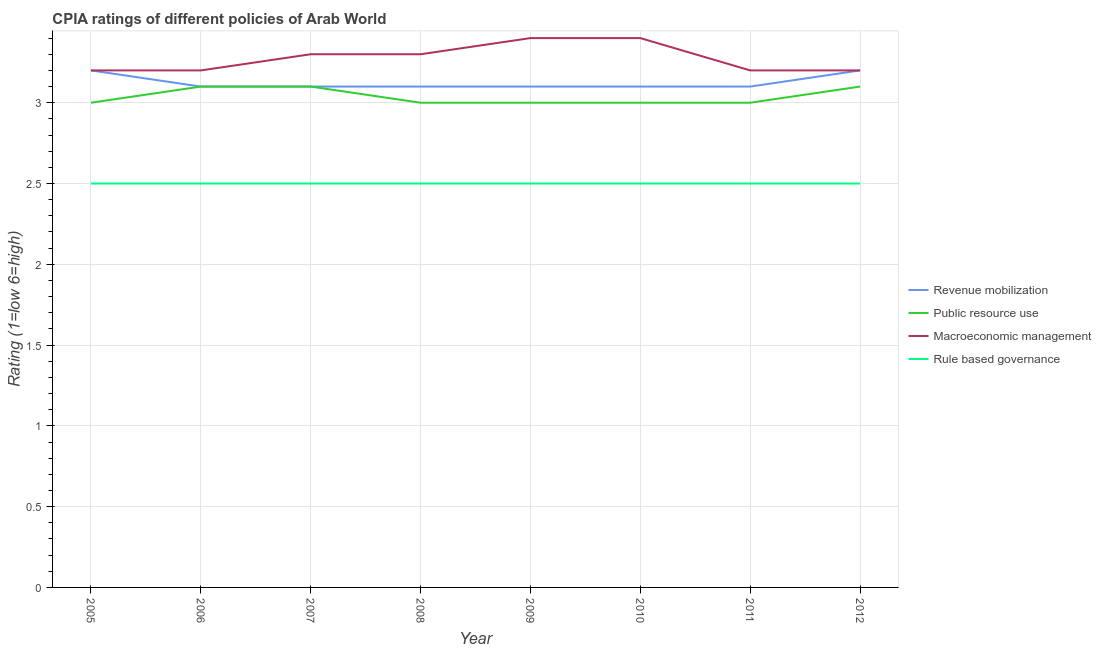How many different coloured lines are there?
Offer a very short reply. 4. Across all years, what is the maximum cpia rating of macroeconomic management?
Ensure brevity in your answer.  3.4. In which year was the cpia rating of rule based governance maximum?
Make the answer very short. 2005. What is the total cpia rating of macroeconomic management in the graph?
Keep it short and to the point. 26.2. What is the difference between the cpia rating of revenue mobilization in 2012 and the cpia rating of macroeconomic management in 2010?
Provide a short and direct response. -0.2. What is the average cpia rating of revenue mobilization per year?
Ensure brevity in your answer.  3.12. In the year 2006, what is the difference between the cpia rating of macroeconomic management and cpia rating of revenue mobilization?
Provide a succinct answer. 0.1. In how many years, is the cpia rating of public resource use greater than 2.6?
Offer a terse response. 8. What is the ratio of the cpia rating of rule based governance in 2005 to that in 2010?
Your response must be concise. 1. Is the cpia rating of macroeconomic management in 2009 less than that in 2012?
Give a very brief answer. No. What is the difference between the highest and the lowest cpia rating of revenue mobilization?
Provide a succinct answer. 0.1. Is the sum of the cpia rating of public resource use in 2005 and 2012 greater than the maximum cpia rating of rule based governance across all years?
Give a very brief answer. Yes. Is the cpia rating of macroeconomic management strictly less than the cpia rating of public resource use over the years?
Your answer should be compact. No. How many years are there in the graph?
Provide a succinct answer. 8. What is the difference between two consecutive major ticks on the Y-axis?
Ensure brevity in your answer.  0.5. Are the values on the major ticks of Y-axis written in scientific E-notation?
Offer a very short reply. No. Does the graph contain any zero values?
Offer a terse response. No. Where does the legend appear in the graph?
Provide a short and direct response. Center right. How are the legend labels stacked?
Keep it short and to the point. Vertical. What is the title of the graph?
Provide a short and direct response. CPIA ratings of different policies of Arab World. What is the label or title of the X-axis?
Ensure brevity in your answer.  Year. What is the Rating (1=low 6=high) in Macroeconomic management in 2005?
Your answer should be very brief. 3.2. What is the Rating (1=low 6=high) of Rule based governance in 2005?
Keep it short and to the point. 2.5. What is the Rating (1=low 6=high) in Macroeconomic management in 2006?
Your answer should be very brief. 3.2. What is the Rating (1=low 6=high) in Rule based governance in 2006?
Ensure brevity in your answer.  2.5. What is the Rating (1=low 6=high) in Rule based governance in 2007?
Provide a short and direct response. 2.5. What is the Rating (1=low 6=high) of Revenue mobilization in 2008?
Your answer should be very brief. 3.1. What is the Rating (1=low 6=high) in Macroeconomic management in 2008?
Make the answer very short. 3.3. What is the Rating (1=low 6=high) in Macroeconomic management in 2009?
Provide a short and direct response. 3.4. What is the Rating (1=low 6=high) of Revenue mobilization in 2010?
Make the answer very short. 3.1. What is the Rating (1=low 6=high) in Public resource use in 2010?
Give a very brief answer. 3. What is the Rating (1=low 6=high) in Macroeconomic management in 2010?
Provide a short and direct response. 3.4. What is the Rating (1=low 6=high) of Rule based governance in 2011?
Give a very brief answer. 2.5. What is the Rating (1=low 6=high) of Revenue mobilization in 2012?
Your answer should be very brief. 3.2. Across all years, what is the maximum Rating (1=low 6=high) of Revenue mobilization?
Offer a terse response. 3.2. Across all years, what is the maximum Rating (1=low 6=high) in Macroeconomic management?
Offer a very short reply. 3.4. Across all years, what is the maximum Rating (1=low 6=high) in Rule based governance?
Offer a terse response. 2.5. What is the total Rating (1=low 6=high) of Revenue mobilization in the graph?
Your answer should be very brief. 25. What is the total Rating (1=low 6=high) in Public resource use in the graph?
Your answer should be compact. 24.3. What is the total Rating (1=low 6=high) of Macroeconomic management in the graph?
Your answer should be compact. 26.2. What is the difference between the Rating (1=low 6=high) in Rule based governance in 2005 and that in 2006?
Offer a terse response. 0. What is the difference between the Rating (1=low 6=high) in Revenue mobilization in 2005 and that in 2007?
Your response must be concise. 0.1. What is the difference between the Rating (1=low 6=high) in Macroeconomic management in 2005 and that in 2007?
Offer a very short reply. -0.1. What is the difference between the Rating (1=low 6=high) of Revenue mobilization in 2005 and that in 2008?
Ensure brevity in your answer.  0.1. What is the difference between the Rating (1=low 6=high) in Macroeconomic management in 2005 and that in 2008?
Give a very brief answer. -0.1. What is the difference between the Rating (1=low 6=high) in Rule based governance in 2005 and that in 2008?
Your response must be concise. 0. What is the difference between the Rating (1=low 6=high) of Revenue mobilization in 2005 and that in 2009?
Keep it short and to the point. 0.1. What is the difference between the Rating (1=low 6=high) of Public resource use in 2005 and that in 2010?
Your answer should be compact. 0. What is the difference between the Rating (1=low 6=high) in Rule based governance in 2005 and that in 2010?
Ensure brevity in your answer.  0. What is the difference between the Rating (1=low 6=high) in Public resource use in 2005 and that in 2011?
Keep it short and to the point. 0. What is the difference between the Rating (1=low 6=high) of Macroeconomic management in 2005 and that in 2011?
Ensure brevity in your answer.  0. What is the difference between the Rating (1=low 6=high) in Rule based governance in 2005 and that in 2011?
Provide a succinct answer. 0. What is the difference between the Rating (1=low 6=high) in Public resource use in 2005 and that in 2012?
Keep it short and to the point. -0.1. What is the difference between the Rating (1=low 6=high) in Rule based governance in 2005 and that in 2012?
Provide a short and direct response. 0. What is the difference between the Rating (1=low 6=high) in Revenue mobilization in 2006 and that in 2007?
Your response must be concise. 0. What is the difference between the Rating (1=low 6=high) in Revenue mobilization in 2006 and that in 2008?
Your answer should be very brief. 0. What is the difference between the Rating (1=low 6=high) in Macroeconomic management in 2006 and that in 2008?
Offer a terse response. -0.1. What is the difference between the Rating (1=low 6=high) in Revenue mobilization in 2006 and that in 2011?
Make the answer very short. 0. What is the difference between the Rating (1=low 6=high) of Public resource use in 2006 and that in 2011?
Offer a terse response. 0.1. What is the difference between the Rating (1=low 6=high) of Rule based governance in 2006 and that in 2011?
Offer a terse response. 0. What is the difference between the Rating (1=low 6=high) in Revenue mobilization in 2006 and that in 2012?
Ensure brevity in your answer.  -0.1. What is the difference between the Rating (1=low 6=high) in Rule based governance in 2006 and that in 2012?
Provide a succinct answer. 0. What is the difference between the Rating (1=low 6=high) in Revenue mobilization in 2007 and that in 2008?
Make the answer very short. 0. What is the difference between the Rating (1=low 6=high) in Public resource use in 2007 and that in 2008?
Provide a short and direct response. 0.1. What is the difference between the Rating (1=low 6=high) in Public resource use in 2007 and that in 2009?
Give a very brief answer. 0.1. What is the difference between the Rating (1=low 6=high) in Macroeconomic management in 2007 and that in 2009?
Your response must be concise. -0.1. What is the difference between the Rating (1=low 6=high) in Revenue mobilization in 2007 and that in 2010?
Your response must be concise. 0. What is the difference between the Rating (1=low 6=high) of Revenue mobilization in 2007 and that in 2011?
Your response must be concise. 0. What is the difference between the Rating (1=low 6=high) in Public resource use in 2007 and that in 2011?
Your response must be concise. 0.1. What is the difference between the Rating (1=low 6=high) in Macroeconomic management in 2007 and that in 2011?
Your answer should be very brief. 0.1. What is the difference between the Rating (1=low 6=high) of Rule based governance in 2007 and that in 2011?
Offer a very short reply. 0. What is the difference between the Rating (1=low 6=high) in Revenue mobilization in 2007 and that in 2012?
Keep it short and to the point. -0.1. What is the difference between the Rating (1=low 6=high) of Public resource use in 2007 and that in 2012?
Give a very brief answer. 0. What is the difference between the Rating (1=low 6=high) of Rule based governance in 2007 and that in 2012?
Offer a terse response. 0. What is the difference between the Rating (1=low 6=high) of Macroeconomic management in 2008 and that in 2009?
Ensure brevity in your answer.  -0.1. What is the difference between the Rating (1=low 6=high) in Public resource use in 2008 and that in 2010?
Provide a short and direct response. 0. What is the difference between the Rating (1=low 6=high) in Public resource use in 2008 and that in 2011?
Give a very brief answer. 0. What is the difference between the Rating (1=low 6=high) of Macroeconomic management in 2008 and that in 2011?
Your answer should be compact. 0.1. What is the difference between the Rating (1=low 6=high) in Public resource use in 2008 and that in 2012?
Provide a short and direct response. -0.1. What is the difference between the Rating (1=low 6=high) in Revenue mobilization in 2009 and that in 2010?
Give a very brief answer. 0. What is the difference between the Rating (1=low 6=high) of Public resource use in 2009 and that in 2010?
Your response must be concise. 0. What is the difference between the Rating (1=low 6=high) of Macroeconomic management in 2009 and that in 2010?
Offer a terse response. 0. What is the difference between the Rating (1=low 6=high) in Revenue mobilization in 2009 and that in 2011?
Provide a short and direct response. 0. What is the difference between the Rating (1=low 6=high) in Public resource use in 2009 and that in 2011?
Your answer should be very brief. 0. What is the difference between the Rating (1=low 6=high) in Macroeconomic management in 2009 and that in 2012?
Your answer should be compact. 0.2. What is the difference between the Rating (1=low 6=high) of Revenue mobilization in 2010 and that in 2011?
Give a very brief answer. 0. What is the difference between the Rating (1=low 6=high) in Revenue mobilization in 2010 and that in 2012?
Your answer should be very brief. -0.1. What is the difference between the Rating (1=low 6=high) of Rule based governance in 2010 and that in 2012?
Offer a very short reply. 0. What is the difference between the Rating (1=low 6=high) in Public resource use in 2011 and that in 2012?
Give a very brief answer. -0.1. What is the difference between the Rating (1=low 6=high) in Rule based governance in 2011 and that in 2012?
Your answer should be compact. 0. What is the difference between the Rating (1=low 6=high) in Revenue mobilization in 2005 and the Rating (1=low 6=high) in Public resource use in 2006?
Offer a terse response. 0.1. What is the difference between the Rating (1=low 6=high) in Revenue mobilization in 2005 and the Rating (1=low 6=high) in Rule based governance in 2006?
Keep it short and to the point. 0.7. What is the difference between the Rating (1=low 6=high) of Public resource use in 2005 and the Rating (1=low 6=high) of Macroeconomic management in 2006?
Provide a succinct answer. -0.2. What is the difference between the Rating (1=low 6=high) of Macroeconomic management in 2005 and the Rating (1=low 6=high) of Rule based governance in 2006?
Give a very brief answer. 0.7. What is the difference between the Rating (1=low 6=high) of Revenue mobilization in 2005 and the Rating (1=low 6=high) of Public resource use in 2007?
Offer a very short reply. 0.1. What is the difference between the Rating (1=low 6=high) in Revenue mobilization in 2005 and the Rating (1=low 6=high) in Rule based governance in 2007?
Your response must be concise. 0.7. What is the difference between the Rating (1=low 6=high) of Public resource use in 2005 and the Rating (1=low 6=high) of Macroeconomic management in 2007?
Your response must be concise. -0.3. What is the difference between the Rating (1=low 6=high) of Public resource use in 2005 and the Rating (1=low 6=high) of Rule based governance in 2007?
Your response must be concise. 0.5. What is the difference between the Rating (1=low 6=high) in Revenue mobilization in 2005 and the Rating (1=low 6=high) in Public resource use in 2008?
Provide a succinct answer. 0.2. What is the difference between the Rating (1=low 6=high) of Revenue mobilization in 2005 and the Rating (1=low 6=high) of Rule based governance in 2008?
Offer a very short reply. 0.7. What is the difference between the Rating (1=low 6=high) in Public resource use in 2005 and the Rating (1=low 6=high) in Rule based governance in 2008?
Give a very brief answer. 0.5. What is the difference between the Rating (1=low 6=high) of Revenue mobilization in 2005 and the Rating (1=low 6=high) of Public resource use in 2009?
Make the answer very short. 0.2. What is the difference between the Rating (1=low 6=high) in Public resource use in 2005 and the Rating (1=low 6=high) in Macroeconomic management in 2009?
Your answer should be very brief. -0.4. What is the difference between the Rating (1=low 6=high) in Public resource use in 2005 and the Rating (1=low 6=high) in Rule based governance in 2009?
Offer a terse response. 0.5. What is the difference between the Rating (1=low 6=high) of Macroeconomic management in 2005 and the Rating (1=low 6=high) of Rule based governance in 2009?
Your response must be concise. 0.7. What is the difference between the Rating (1=low 6=high) in Revenue mobilization in 2005 and the Rating (1=low 6=high) in Rule based governance in 2010?
Provide a succinct answer. 0.7. What is the difference between the Rating (1=low 6=high) in Public resource use in 2005 and the Rating (1=low 6=high) in Rule based governance in 2010?
Give a very brief answer. 0.5. What is the difference between the Rating (1=low 6=high) of Macroeconomic management in 2005 and the Rating (1=low 6=high) of Rule based governance in 2010?
Your response must be concise. 0.7. What is the difference between the Rating (1=low 6=high) of Revenue mobilization in 2005 and the Rating (1=low 6=high) of Public resource use in 2011?
Give a very brief answer. 0.2. What is the difference between the Rating (1=low 6=high) in Revenue mobilization in 2005 and the Rating (1=low 6=high) in Macroeconomic management in 2011?
Provide a succinct answer. 0. What is the difference between the Rating (1=low 6=high) in Revenue mobilization in 2005 and the Rating (1=low 6=high) in Rule based governance in 2011?
Ensure brevity in your answer.  0.7. What is the difference between the Rating (1=low 6=high) of Public resource use in 2005 and the Rating (1=low 6=high) of Rule based governance in 2012?
Your answer should be very brief. 0.5. What is the difference between the Rating (1=low 6=high) in Public resource use in 2006 and the Rating (1=low 6=high) in Rule based governance in 2007?
Keep it short and to the point. 0.6. What is the difference between the Rating (1=low 6=high) in Macroeconomic management in 2006 and the Rating (1=low 6=high) in Rule based governance in 2007?
Your response must be concise. 0.7. What is the difference between the Rating (1=low 6=high) in Revenue mobilization in 2006 and the Rating (1=low 6=high) in Macroeconomic management in 2008?
Give a very brief answer. -0.2. What is the difference between the Rating (1=low 6=high) in Public resource use in 2006 and the Rating (1=low 6=high) in Macroeconomic management in 2008?
Make the answer very short. -0.2. What is the difference between the Rating (1=low 6=high) in Public resource use in 2006 and the Rating (1=low 6=high) in Rule based governance in 2008?
Your answer should be very brief. 0.6. What is the difference between the Rating (1=low 6=high) of Macroeconomic management in 2006 and the Rating (1=low 6=high) of Rule based governance in 2008?
Provide a succinct answer. 0.7. What is the difference between the Rating (1=low 6=high) of Revenue mobilization in 2006 and the Rating (1=low 6=high) of Public resource use in 2009?
Offer a terse response. 0.1. What is the difference between the Rating (1=low 6=high) in Revenue mobilization in 2006 and the Rating (1=low 6=high) in Macroeconomic management in 2009?
Offer a terse response. -0.3. What is the difference between the Rating (1=low 6=high) in Revenue mobilization in 2006 and the Rating (1=low 6=high) in Rule based governance in 2009?
Ensure brevity in your answer.  0.6. What is the difference between the Rating (1=low 6=high) in Public resource use in 2006 and the Rating (1=low 6=high) in Macroeconomic management in 2009?
Offer a terse response. -0.3. What is the difference between the Rating (1=low 6=high) in Public resource use in 2006 and the Rating (1=low 6=high) in Rule based governance in 2009?
Your answer should be very brief. 0.6. What is the difference between the Rating (1=low 6=high) of Macroeconomic management in 2006 and the Rating (1=low 6=high) of Rule based governance in 2009?
Keep it short and to the point. 0.7. What is the difference between the Rating (1=low 6=high) of Revenue mobilization in 2006 and the Rating (1=low 6=high) of Public resource use in 2010?
Provide a short and direct response. 0.1. What is the difference between the Rating (1=low 6=high) of Revenue mobilization in 2006 and the Rating (1=low 6=high) of Rule based governance in 2010?
Your response must be concise. 0.6. What is the difference between the Rating (1=low 6=high) of Public resource use in 2006 and the Rating (1=low 6=high) of Macroeconomic management in 2010?
Make the answer very short. -0.3. What is the difference between the Rating (1=low 6=high) in Public resource use in 2006 and the Rating (1=low 6=high) in Macroeconomic management in 2011?
Your answer should be very brief. -0.1. What is the difference between the Rating (1=low 6=high) of Revenue mobilization in 2006 and the Rating (1=low 6=high) of Public resource use in 2012?
Your response must be concise. 0. What is the difference between the Rating (1=low 6=high) of Revenue mobilization in 2006 and the Rating (1=low 6=high) of Macroeconomic management in 2012?
Offer a terse response. -0.1. What is the difference between the Rating (1=low 6=high) of Revenue mobilization in 2007 and the Rating (1=low 6=high) of Macroeconomic management in 2008?
Make the answer very short. -0.2. What is the difference between the Rating (1=low 6=high) of Revenue mobilization in 2007 and the Rating (1=low 6=high) of Rule based governance in 2008?
Keep it short and to the point. 0.6. What is the difference between the Rating (1=low 6=high) of Public resource use in 2007 and the Rating (1=low 6=high) of Macroeconomic management in 2008?
Keep it short and to the point. -0.2. What is the difference between the Rating (1=low 6=high) in Macroeconomic management in 2007 and the Rating (1=low 6=high) in Rule based governance in 2008?
Offer a very short reply. 0.8. What is the difference between the Rating (1=low 6=high) in Revenue mobilization in 2007 and the Rating (1=low 6=high) in Macroeconomic management in 2009?
Give a very brief answer. -0.3. What is the difference between the Rating (1=low 6=high) of Public resource use in 2007 and the Rating (1=low 6=high) of Macroeconomic management in 2009?
Provide a short and direct response. -0.3. What is the difference between the Rating (1=low 6=high) in Public resource use in 2007 and the Rating (1=low 6=high) in Rule based governance in 2009?
Keep it short and to the point. 0.6. What is the difference between the Rating (1=low 6=high) in Macroeconomic management in 2007 and the Rating (1=low 6=high) in Rule based governance in 2009?
Provide a short and direct response. 0.8. What is the difference between the Rating (1=low 6=high) of Public resource use in 2007 and the Rating (1=low 6=high) of Macroeconomic management in 2010?
Your response must be concise. -0.3. What is the difference between the Rating (1=low 6=high) in Public resource use in 2007 and the Rating (1=low 6=high) in Rule based governance in 2010?
Offer a very short reply. 0.6. What is the difference between the Rating (1=low 6=high) of Macroeconomic management in 2007 and the Rating (1=low 6=high) of Rule based governance in 2010?
Your response must be concise. 0.8. What is the difference between the Rating (1=low 6=high) of Revenue mobilization in 2007 and the Rating (1=low 6=high) of Public resource use in 2011?
Make the answer very short. 0.1. What is the difference between the Rating (1=low 6=high) of Public resource use in 2007 and the Rating (1=low 6=high) of Rule based governance in 2011?
Your answer should be compact. 0.6. What is the difference between the Rating (1=low 6=high) in Revenue mobilization in 2007 and the Rating (1=low 6=high) in Public resource use in 2012?
Your response must be concise. 0. What is the difference between the Rating (1=low 6=high) in Revenue mobilization in 2007 and the Rating (1=low 6=high) in Macroeconomic management in 2012?
Provide a short and direct response. -0.1. What is the difference between the Rating (1=low 6=high) in Revenue mobilization in 2007 and the Rating (1=low 6=high) in Rule based governance in 2012?
Make the answer very short. 0.6. What is the difference between the Rating (1=low 6=high) of Public resource use in 2007 and the Rating (1=low 6=high) of Macroeconomic management in 2012?
Provide a short and direct response. -0.1. What is the difference between the Rating (1=low 6=high) of Public resource use in 2007 and the Rating (1=low 6=high) of Rule based governance in 2012?
Keep it short and to the point. 0.6. What is the difference between the Rating (1=low 6=high) of Revenue mobilization in 2008 and the Rating (1=low 6=high) of Public resource use in 2009?
Give a very brief answer. 0.1. What is the difference between the Rating (1=low 6=high) of Revenue mobilization in 2008 and the Rating (1=low 6=high) of Macroeconomic management in 2009?
Offer a terse response. -0.3. What is the difference between the Rating (1=low 6=high) of Revenue mobilization in 2008 and the Rating (1=low 6=high) of Rule based governance in 2009?
Offer a very short reply. 0.6. What is the difference between the Rating (1=low 6=high) of Public resource use in 2008 and the Rating (1=low 6=high) of Macroeconomic management in 2009?
Your response must be concise. -0.4. What is the difference between the Rating (1=low 6=high) of Public resource use in 2008 and the Rating (1=low 6=high) of Rule based governance in 2009?
Make the answer very short. 0.5. What is the difference between the Rating (1=low 6=high) of Revenue mobilization in 2008 and the Rating (1=low 6=high) of Public resource use in 2010?
Give a very brief answer. 0.1. What is the difference between the Rating (1=low 6=high) in Revenue mobilization in 2008 and the Rating (1=low 6=high) in Macroeconomic management in 2010?
Your answer should be very brief. -0.3. What is the difference between the Rating (1=low 6=high) in Public resource use in 2008 and the Rating (1=low 6=high) in Macroeconomic management in 2010?
Keep it short and to the point. -0.4. What is the difference between the Rating (1=low 6=high) in Revenue mobilization in 2008 and the Rating (1=low 6=high) in Public resource use in 2011?
Offer a terse response. 0.1. What is the difference between the Rating (1=low 6=high) of Revenue mobilization in 2008 and the Rating (1=low 6=high) of Macroeconomic management in 2011?
Ensure brevity in your answer.  -0.1. What is the difference between the Rating (1=low 6=high) of Revenue mobilization in 2008 and the Rating (1=low 6=high) of Rule based governance in 2011?
Keep it short and to the point. 0.6. What is the difference between the Rating (1=low 6=high) of Public resource use in 2008 and the Rating (1=low 6=high) of Macroeconomic management in 2011?
Your answer should be compact. -0.2. What is the difference between the Rating (1=low 6=high) in Public resource use in 2008 and the Rating (1=low 6=high) in Rule based governance in 2011?
Give a very brief answer. 0.5. What is the difference between the Rating (1=low 6=high) in Macroeconomic management in 2008 and the Rating (1=low 6=high) in Rule based governance in 2011?
Make the answer very short. 0.8. What is the difference between the Rating (1=low 6=high) in Revenue mobilization in 2008 and the Rating (1=low 6=high) in Public resource use in 2012?
Your response must be concise. 0. What is the difference between the Rating (1=low 6=high) in Revenue mobilization in 2008 and the Rating (1=low 6=high) in Rule based governance in 2012?
Ensure brevity in your answer.  0.6. What is the difference between the Rating (1=low 6=high) in Public resource use in 2008 and the Rating (1=low 6=high) in Macroeconomic management in 2012?
Provide a short and direct response. -0.2. What is the difference between the Rating (1=low 6=high) in Revenue mobilization in 2009 and the Rating (1=low 6=high) in Macroeconomic management in 2010?
Offer a terse response. -0.3. What is the difference between the Rating (1=low 6=high) of Revenue mobilization in 2009 and the Rating (1=low 6=high) of Rule based governance in 2010?
Your answer should be compact. 0.6. What is the difference between the Rating (1=low 6=high) in Public resource use in 2009 and the Rating (1=low 6=high) in Rule based governance in 2010?
Your response must be concise. 0.5. What is the difference between the Rating (1=low 6=high) of Revenue mobilization in 2009 and the Rating (1=low 6=high) of Macroeconomic management in 2011?
Make the answer very short. -0.1. What is the difference between the Rating (1=low 6=high) in Public resource use in 2009 and the Rating (1=low 6=high) in Macroeconomic management in 2011?
Offer a terse response. -0.2. What is the difference between the Rating (1=low 6=high) of Public resource use in 2009 and the Rating (1=low 6=high) of Macroeconomic management in 2012?
Provide a succinct answer. -0.2. What is the difference between the Rating (1=low 6=high) of Public resource use in 2010 and the Rating (1=low 6=high) of Rule based governance in 2011?
Give a very brief answer. 0.5. What is the difference between the Rating (1=low 6=high) in Revenue mobilization in 2010 and the Rating (1=low 6=high) in Public resource use in 2012?
Offer a very short reply. 0. What is the difference between the Rating (1=low 6=high) of Revenue mobilization in 2010 and the Rating (1=low 6=high) of Macroeconomic management in 2012?
Your answer should be very brief. -0.1. What is the difference between the Rating (1=low 6=high) in Macroeconomic management in 2011 and the Rating (1=low 6=high) in Rule based governance in 2012?
Provide a short and direct response. 0.7. What is the average Rating (1=low 6=high) of Revenue mobilization per year?
Your response must be concise. 3.12. What is the average Rating (1=low 6=high) in Public resource use per year?
Your answer should be compact. 3.04. What is the average Rating (1=low 6=high) in Macroeconomic management per year?
Your answer should be very brief. 3.27. What is the average Rating (1=low 6=high) in Rule based governance per year?
Offer a very short reply. 2.5. In the year 2005, what is the difference between the Rating (1=low 6=high) in Revenue mobilization and Rating (1=low 6=high) in Public resource use?
Ensure brevity in your answer.  0.2. In the year 2005, what is the difference between the Rating (1=low 6=high) of Revenue mobilization and Rating (1=low 6=high) of Rule based governance?
Make the answer very short. 0.7. In the year 2005, what is the difference between the Rating (1=low 6=high) in Public resource use and Rating (1=low 6=high) in Macroeconomic management?
Make the answer very short. -0.2. In the year 2006, what is the difference between the Rating (1=low 6=high) of Revenue mobilization and Rating (1=low 6=high) of Public resource use?
Keep it short and to the point. 0. In the year 2006, what is the difference between the Rating (1=low 6=high) in Revenue mobilization and Rating (1=low 6=high) in Macroeconomic management?
Provide a short and direct response. -0.1. In the year 2006, what is the difference between the Rating (1=low 6=high) in Public resource use and Rating (1=low 6=high) in Macroeconomic management?
Offer a very short reply. -0.1. In the year 2006, what is the difference between the Rating (1=low 6=high) in Public resource use and Rating (1=low 6=high) in Rule based governance?
Ensure brevity in your answer.  0.6. In the year 2007, what is the difference between the Rating (1=low 6=high) of Revenue mobilization and Rating (1=low 6=high) of Public resource use?
Keep it short and to the point. 0. In the year 2007, what is the difference between the Rating (1=low 6=high) in Public resource use and Rating (1=low 6=high) in Macroeconomic management?
Provide a short and direct response. -0.2. In the year 2007, what is the difference between the Rating (1=low 6=high) of Public resource use and Rating (1=low 6=high) of Rule based governance?
Make the answer very short. 0.6. In the year 2007, what is the difference between the Rating (1=low 6=high) of Macroeconomic management and Rating (1=low 6=high) of Rule based governance?
Offer a terse response. 0.8. In the year 2008, what is the difference between the Rating (1=low 6=high) of Revenue mobilization and Rating (1=low 6=high) of Macroeconomic management?
Make the answer very short. -0.2. In the year 2008, what is the difference between the Rating (1=low 6=high) of Revenue mobilization and Rating (1=low 6=high) of Rule based governance?
Offer a terse response. 0.6. In the year 2009, what is the difference between the Rating (1=low 6=high) in Revenue mobilization and Rating (1=low 6=high) in Public resource use?
Offer a very short reply. 0.1. In the year 2009, what is the difference between the Rating (1=low 6=high) in Revenue mobilization and Rating (1=low 6=high) in Macroeconomic management?
Offer a very short reply. -0.3. In the year 2009, what is the difference between the Rating (1=low 6=high) of Revenue mobilization and Rating (1=low 6=high) of Rule based governance?
Your response must be concise. 0.6. In the year 2009, what is the difference between the Rating (1=low 6=high) of Macroeconomic management and Rating (1=low 6=high) of Rule based governance?
Give a very brief answer. 0.9. In the year 2010, what is the difference between the Rating (1=low 6=high) of Revenue mobilization and Rating (1=low 6=high) of Public resource use?
Make the answer very short. 0.1. In the year 2010, what is the difference between the Rating (1=low 6=high) of Revenue mobilization and Rating (1=low 6=high) of Macroeconomic management?
Provide a short and direct response. -0.3. In the year 2010, what is the difference between the Rating (1=low 6=high) of Revenue mobilization and Rating (1=low 6=high) of Rule based governance?
Offer a terse response. 0.6. In the year 2010, what is the difference between the Rating (1=low 6=high) of Public resource use and Rating (1=low 6=high) of Macroeconomic management?
Offer a very short reply. -0.4. In the year 2010, what is the difference between the Rating (1=low 6=high) of Public resource use and Rating (1=low 6=high) of Rule based governance?
Offer a terse response. 0.5. In the year 2011, what is the difference between the Rating (1=low 6=high) of Revenue mobilization and Rating (1=low 6=high) of Macroeconomic management?
Your answer should be very brief. -0.1. In the year 2011, what is the difference between the Rating (1=low 6=high) of Macroeconomic management and Rating (1=low 6=high) of Rule based governance?
Your answer should be compact. 0.7. In the year 2012, what is the difference between the Rating (1=low 6=high) of Public resource use and Rating (1=low 6=high) of Macroeconomic management?
Your answer should be compact. -0.1. In the year 2012, what is the difference between the Rating (1=low 6=high) in Public resource use and Rating (1=low 6=high) in Rule based governance?
Your answer should be very brief. 0.6. What is the ratio of the Rating (1=low 6=high) in Revenue mobilization in 2005 to that in 2006?
Provide a short and direct response. 1.03. What is the ratio of the Rating (1=low 6=high) in Macroeconomic management in 2005 to that in 2006?
Provide a succinct answer. 1. What is the ratio of the Rating (1=low 6=high) in Revenue mobilization in 2005 to that in 2007?
Offer a terse response. 1.03. What is the ratio of the Rating (1=low 6=high) of Public resource use in 2005 to that in 2007?
Make the answer very short. 0.97. What is the ratio of the Rating (1=low 6=high) of Macroeconomic management in 2005 to that in 2007?
Make the answer very short. 0.97. What is the ratio of the Rating (1=low 6=high) of Revenue mobilization in 2005 to that in 2008?
Ensure brevity in your answer.  1.03. What is the ratio of the Rating (1=low 6=high) in Public resource use in 2005 to that in 2008?
Provide a succinct answer. 1. What is the ratio of the Rating (1=low 6=high) of Macroeconomic management in 2005 to that in 2008?
Offer a terse response. 0.97. What is the ratio of the Rating (1=low 6=high) in Rule based governance in 2005 to that in 2008?
Provide a short and direct response. 1. What is the ratio of the Rating (1=low 6=high) of Revenue mobilization in 2005 to that in 2009?
Offer a very short reply. 1.03. What is the ratio of the Rating (1=low 6=high) in Public resource use in 2005 to that in 2009?
Give a very brief answer. 1. What is the ratio of the Rating (1=low 6=high) of Revenue mobilization in 2005 to that in 2010?
Provide a short and direct response. 1.03. What is the ratio of the Rating (1=low 6=high) of Macroeconomic management in 2005 to that in 2010?
Provide a succinct answer. 0.94. What is the ratio of the Rating (1=low 6=high) in Rule based governance in 2005 to that in 2010?
Offer a terse response. 1. What is the ratio of the Rating (1=low 6=high) in Revenue mobilization in 2005 to that in 2011?
Provide a succinct answer. 1.03. What is the ratio of the Rating (1=low 6=high) of Public resource use in 2005 to that in 2011?
Your answer should be compact. 1. What is the ratio of the Rating (1=low 6=high) of Rule based governance in 2005 to that in 2011?
Ensure brevity in your answer.  1. What is the ratio of the Rating (1=low 6=high) in Public resource use in 2005 to that in 2012?
Keep it short and to the point. 0.97. What is the ratio of the Rating (1=low 6=high) in Macroeconomic management in 2006 to that in 2007?
Keep it short and to the point. 0.97. What is the ratio of the Rating (1=low 6=high) in Rule based governance in 2006 to that in 2007?
Offer a very short reply. 1. What is the ratio of the Rating (1=low 6=high) in Revenue mobilization in 2006 to that in 2008?
Offer a terse response. 1. What is the ratio of the Rating (1=low 6=high) in Macroeconomic management in 2006 to that in 2008?
Offer a terse response. 0.97. What is the ratio of the Rating (1=low 6=high) of Revenue mobilization in 2006 to that in 2009?
Offer a very short reply. 1. What is the ratio of the Rating (1=low 6=high) in Macroeconomic management in 2006 to that in 2009?
Provide a short and direct response. 0.94. What is the ratio of the Rating (1=low 6=high) in Rule based governance in 2006 to that in 2009?
Offer a very short reply. 1. What is the ratio of the Rating (1=low 6=high) of Revenue mobilization in 2006 to that in 2011?
Provide a succinct answer. 1. What is the ratio of the Rating (1=low 6=high) in Public resource use in 2006 to that in 2011?
Your answer should be compact. 1.03. What is the ratio of the Rating (1=low 6=high) of Revenue mobilization in 2006 to that in 2012?
Your response must be concise. 0.97. What is the ratio of the Rating (1=low 6=high) of Public resource use in 2006 to that in 2012?
Offer a terse response. 1. What is the ratio of the Rating (1=low 6=high) in Rule based governance in 2006 to that in 2012?
Provide a short and direct response. 1. What is the ratio of the Rating (1=low 6=high) of Public resource use in 2007 to that in 2008?
Your response must be concise. 1.03. What is the ratio of the Rating (1=low 6=high) of Public resource use in 2007 to that in 2009?
Your answer should be compact. 1.03. What is the ratio of the Rating (1=low 6=high) of Macroeconomic management in 2007 to that in 2009?
Keep it short and to the point. 0.97. What is the ratio of the Rating (1=low 6=high) in Rule based governance in 2007 to that in 2009?
Your response must be concise. 1. What is the ratio of the Rating (1=low 6=high) in Revenue mobilization in 2007 to that in 2010?
Give a very brief answer. 1. What is the ratio of the Rating (1=low 6=high) in Public resource use in 2007 to that in 2010?
Offer a very short reply. 1.03. What is the ratio of the Rating (1=low 6=high) in Macroeconomic management in 2007 to that in 2010?
Give a very brief answer. 0.97. What is the ratio of the Rating (1=low 6=high) in Macroeconomic management in 2007 to that in 2011?
Your response must be concise. 1.03. What is the ratio of the Rating (1=low 6=high) in Rule based governance in 2007 to that in 2011?
Provide a short and direct response. 1. What is the ratio of the Rating (1=low 6=high) of Revenue mobilization in 2007 to that in 2012?
Your answer should be very brief. 0.97. What is the ratio of the Rating (1=low 6=high) of Public resource use in 2007 to that in 2012?
Give a very brief answer. 1. What is the ratio of the Rating (1=low 6=high) in Macroeconomic management in 2007 to that in 2012?
Provide a short and direct response. 1.03. What is the ratio of the Rating (1=low 6=high) of Revenue mobilization in 2008 to that in 2009?
Offer a terse response. 1. What is the ratio of the Rating (1=low 6=high) in Macroeconomic management in 2008 to that in 2009?
Make the answer very short. 0.97. What is the ratio of the Rating (1=low 6=high) in Rule based governance in 2008 to that in 2009?
Provide a succinct answer. 1. What is the ratio of the Rating (1=low 6=high) of Revenue mobilization in 2008 to that in 2010?
Ensure brevity in your answer.  1. What is the ratio of the Rating (1=low 6=high) in Macroeconomic management in 2008 to that in 2010?
Your answer should be compact. 0.97. What is the ratio of the Rating (1=low 6=high) of Public resource use in 2008 to that in 2011?
Your response must be concise. 1. What is the ratio of the Rating (1=low 6=high) of Macroeconomic management in 2008 to that in 2011?
Give a very brief answer. 1.03. What is the ratio of the Rating (1=low 6=high) in Rule based governance in 2008 to that in 2011?
Offer a very short reply. 1. What is the ratio of the Rating (1=low 6=high) in Revenue mobilization in 2008 to that in 2012?
Ensure brevity in your answer.  0.97. What is the ratio of the Rating (1=low 6=high) of Macroeconomic management in 2008 to that in 2012?
Offer a very short reply. 1.03. What is the ratio of the Rating (1=low 6=high) in Rule based governance in 2008 to that in 2012?
Provide a short and direct response. 1. What is the ratio of the Rating (1=low 6=high) in Public resource use in 2009 to that in 2010?
Offer a terse response. 1. What is the ratio of the Rating (1=low 6=high) of Macroeconomic management in 2009 to that in 2010?
Ensure brevity in your answer.  1. What is the ratio of the Rating (1=low 6=high) in Rule based governance in 2009 to that in 2010?
Make the answer very short. 1. What is the ratio of the Rating (1=low 6=high) in Public resource use in 2009 to that in 2011?
Make the answer very short. 1. What is the ratio of the Rating (1=low 6=high) in Rule based governance in 2009 to that in 2011?
Offer a terse response. 1. What is the ratio of the Rating (1=low 6=high) of Revenue mobilization in 2009 to that in 2012?
Offer a terse response. 0.97. What is the ratio of the Rating (1=low 6=high) of Macroeconomic management in 2009 to that in 2012?
Give a very brief answer. 1.06. What is the ratio of the Rating (1=low 6=high) of Rule based governance in 2009 to that in 2012?
Give a very brief answer. 1. What is the ratio of the Rating (1=low 6=high) of Public resource use in 2010 to that in 2011?
Your answer should be compact. 1. What is the ratio of the Rating (1=low 6=high) in Revenue mobilization in 2010 to that in 2012?
Your response must be concise. 0.97. What is the ratio of the Rating (1=low 6=high) in Rule based governance in 2010 to that in 2012?
Offer a very short reply. 1. What is the ratio of the Rating (1=low 6=high) in Revenue mobilization in 2011 to that in 2012?
Keep it short and to the point. 0.97. What is the difference between the highest and the second highest Rating (1=low 6=high) of Public resource use?
Your answer should be compact. 0. 